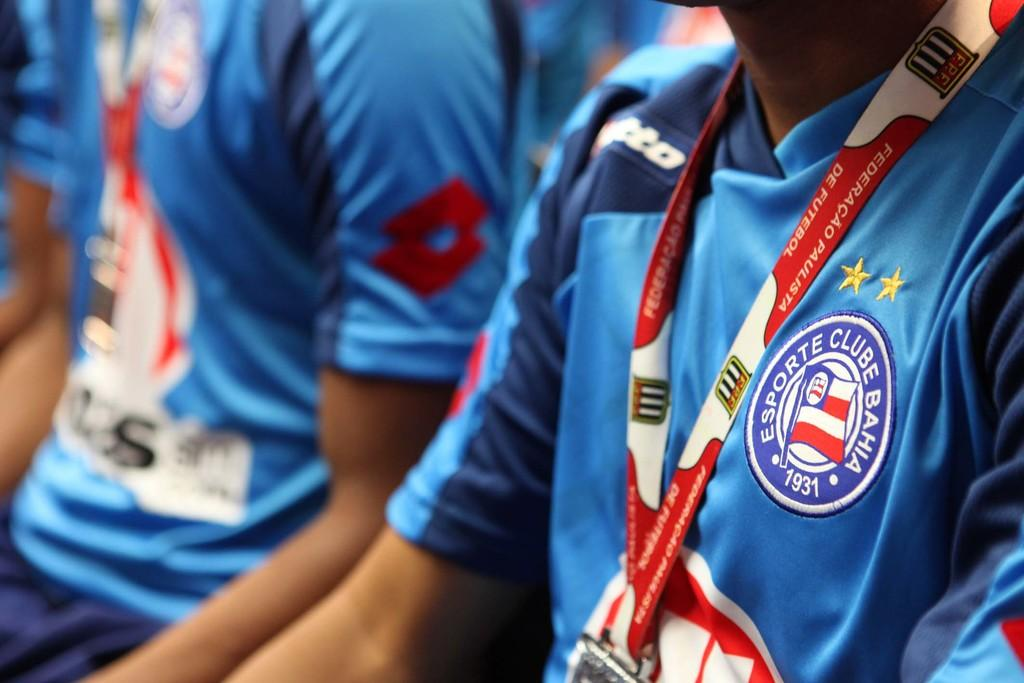<image>
Create a compact narrative representing the image presented. Two men in matching blue jersey and red lanyards are sitting, the emblem on their jersey reads "Esporte Clube Bahia 1931" 